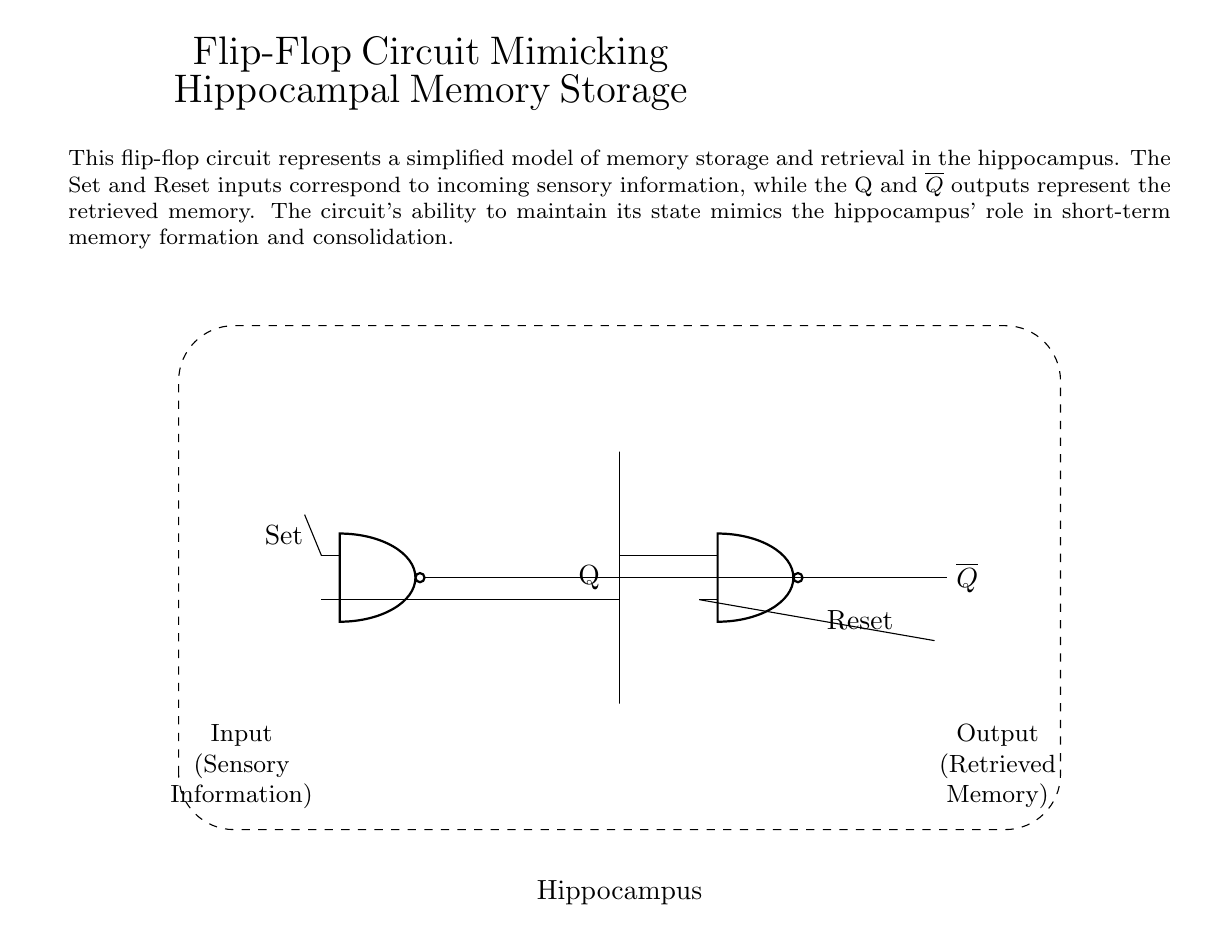What type of logic gates are used in this circuit? The circuit uses NAND gates, which are indicated by the symbols labeled as 'nand port' in the diagram.
Answer: NAND gates What do the Q and not Q outputs represent? The Q output represents the stored memory, while the not Q output represents the inverse state of that memory, reflecting the feedback loop of the flip-flop.
Answer: Retrieved memory What are the inputs to the flip-flop circuit? The inputs named Set and Reset correspond to incoming sensory information, which control the state of the flip-flop circuit to either store or reset memory.
Answer: Set and Reset What is the purpose of the dashed rectangle in the diagram? The dashed rectangle represents the hippocampus, indicating that the flip-flop circuit is a simplified model of memory storage and retrieval functions akin to those of the hippocampus.
Answer: Hippocampus How does the circuit mimic memory formation? The circuit's ability to maintain its output state based on Set and Reset inputs simulates how the hippocampus aids in short-term memory formation and retrieval processes.
Answer: Memory storage What happens when the Reset input is activated? Activating the Reset input will reset the flip-flop, setting the Q output to low, which mimics the process of losing or resetting a memory, similar to hippocampal function.
Answer: Resets memory 